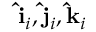<formula> <loc_0><loc_0><loc_500><loc_500>\hat { i } _ { i } , \hat { j } _ { i } , \hat { k } _ { i }</formula> 